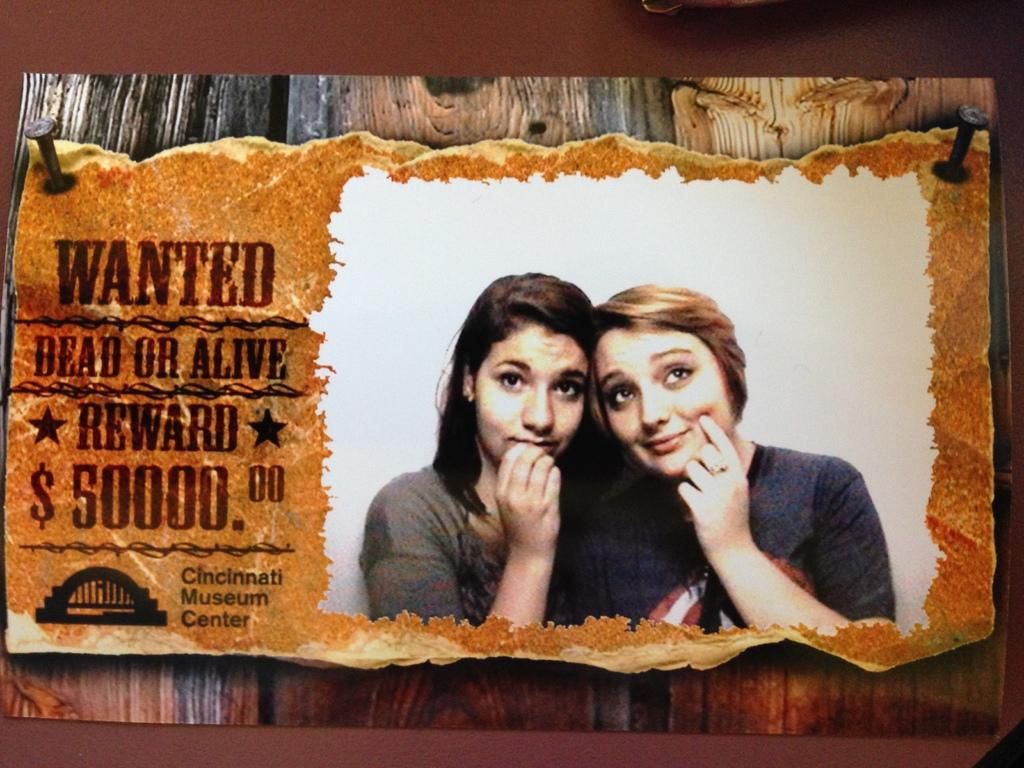Where was the image taken? The image is taken indoors. What can be seen on the poster in the image? There is a poster with images of two women in the image, and there is text on the poster. What is visible in the background of the image? There is a wall in the background of the image. What type of scent can be detected from the poster in the image? There is no scent associated with the poster in the image, as it is a visual representation and not a physical object. 